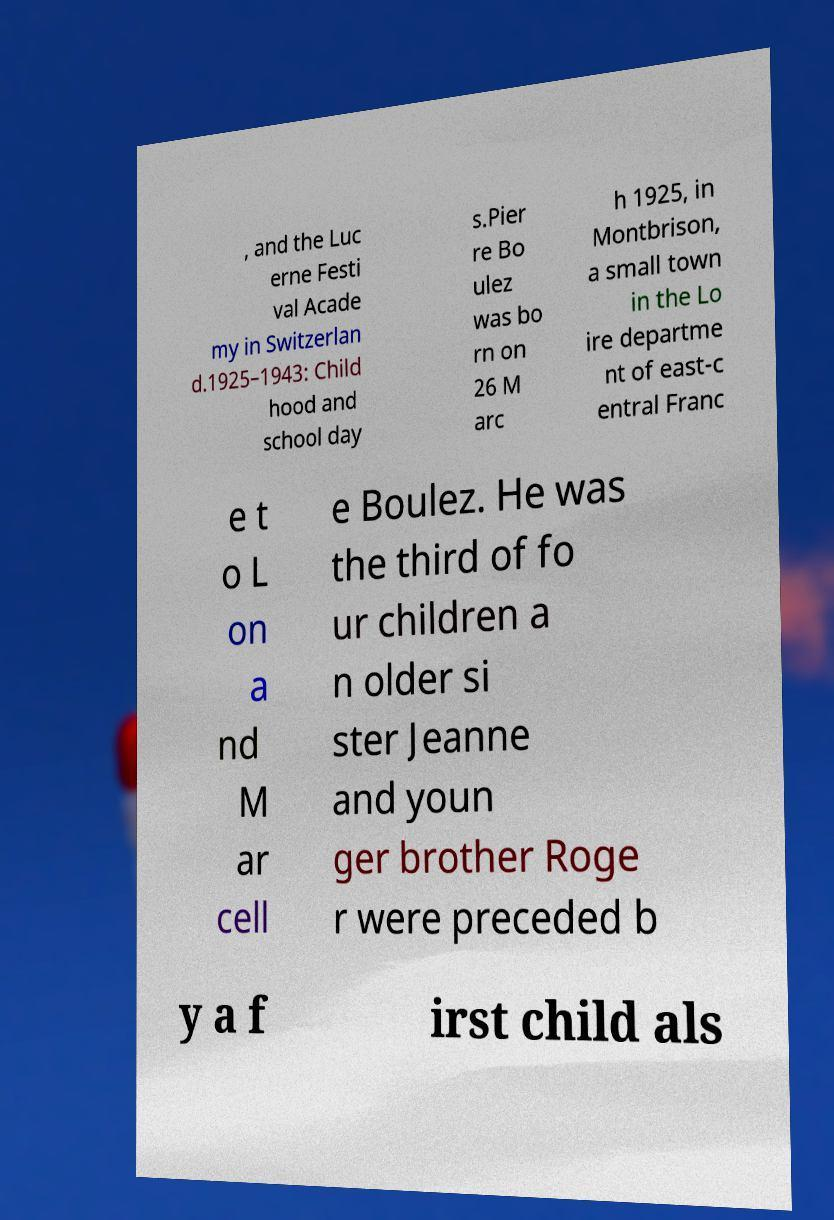Could you extract and type out the text from this image? , and the Luc erne Festi val Acade my in Switzerlan d.1925–1943: Child hood and school day s.Pier re Bo ulez was bo rn on 26 M arc h 1925, in Montbrison, a small town in the Lo ire departme nt of east-c entral Franc e t o L on a nd M ar cell e Boulez. He was the third of fo ur children a n older si ster Jeanne and youn ger brother Roge r were preceded b y a f irst child als 